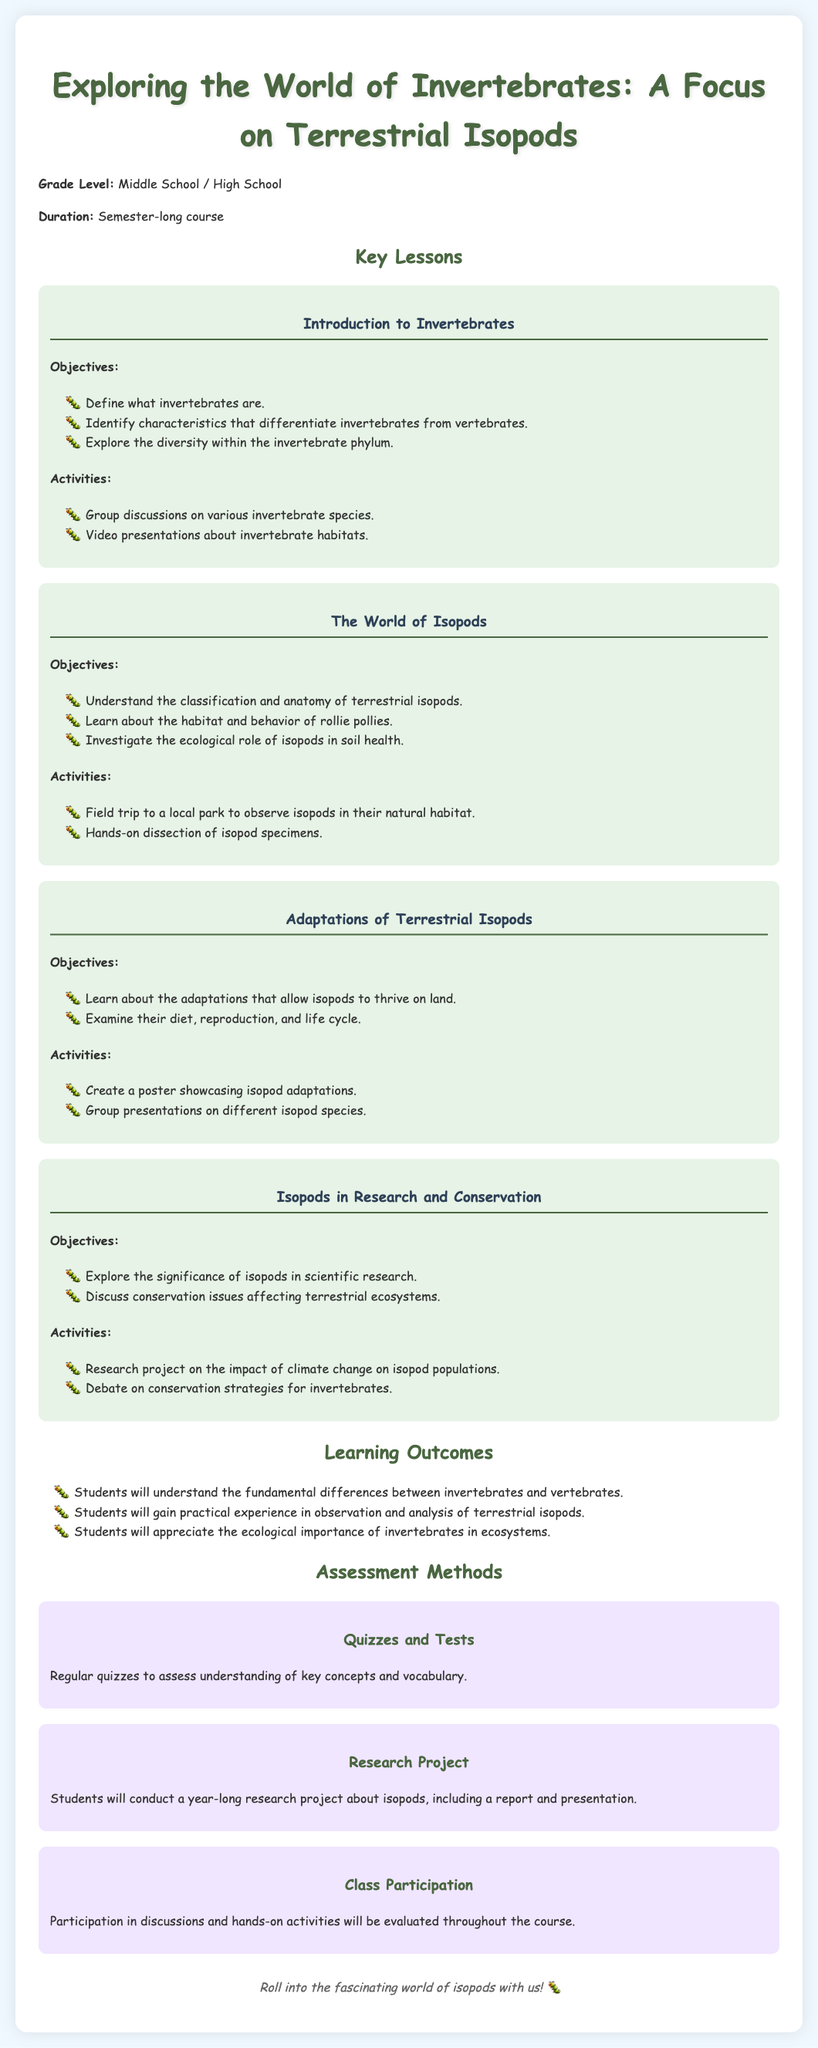What is the title of the document? The title is presented prominently at the top of the document and provides a clear overview of the content.
Answer: Exploring the World of Invertebrates: A Focus on Terrestrial Isopods What is the grade level for the curriculum? The document specifies the intended educational level for the curriculum in the introductory section.
Answer: Middle School / High School What is one of the objectives in the lesson about the World of Isopods? Each lesson has clearly stated objectives that detail what students will learn.
Answer: Understand the classification and anatomy of terrestrial isopods What type of project will students conduct for assessment? The assessment section outlines different evaluation methods, including a specific type of project.
Answer: Research Project How will class participation be evaluated? The assessment methods describe how participation will be tracked and evaluated during the course.
Answer: Throughout the course What ecological role do isopods play according to the lessons? The curriculum mentions the ecological significance of isopods in relation to their environment.
Answer: Soil health What activity involves observing isopods in their habitat? Activities designed for practical learning are detailed within each lesson, highlighting hands-on experiences.
Answer: Field trip to a local park What is a key difference between invertebrates and vertebrates discussed in the curriculum? The document highlights specific characteristics that differentiate these two categories of animals.
Answer: Define what invertebrates are What is an assessment method mentioned for understanding key concepts? The regular evaluation of student knowledge is outlined within the assessment section, focusing on comprehension.
Answer: Quizzes and Tests 